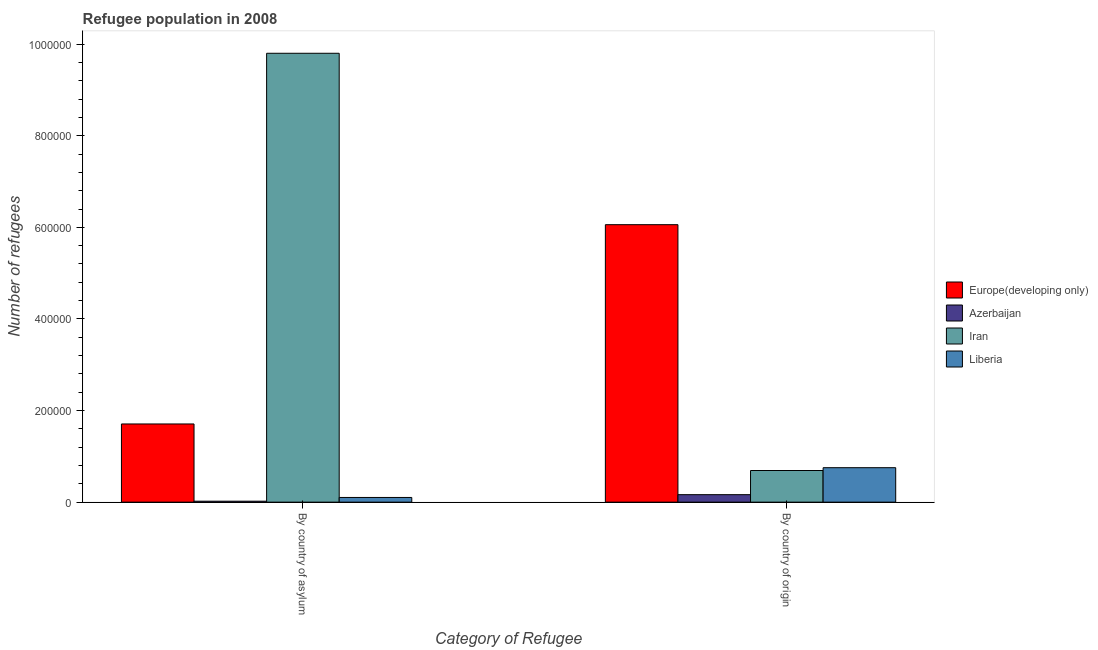How many different coloured bars are there?
Provide a succinct answer. 4. Are the number of bars per tick equal to the number of legend labels?
Your answer should be very brief. Yes. How many bars are there on the 1st tick from the right?
Give a very brief answer. 4. What is the label of the 2nd group of bars from the left?
Give a very brief answer. By country of origin. What is the number of refugees by country of origin in Liberia?
Your answer should be very brief. 7.52e+04. Across all countries, what is the maximum number of refugees by country of asylum?
Provide a succinct answer. 9.80e+05. Across all countries, what is the minimum number of refugees by country of asylum?
Provide a short and direct response. 2061. In which country was the number of refugees by country of origin maximum?
Your answer should be very brief. Europe(developing only). In which country was the number of refugees by country of origin minimum?
Make the answer very short. Azerbaijan. What is the total number of refugees by country of origin in the graph?
Provide a short and direct response. 7.66e+05. What is the difference between the number of refugees by country of origin in Liberia and that in Iran?
Offer a terse response. 6152. What is the difference between the number of refugees by country of asylum in Europe(developing only) and the number of refugees by country of origin in Iran?
Give a very brief answer. 1.02e+05. What is the average number of refugees by country of origin per country?
Provide a succinct answer. 1.92e+05. What is the difference between the number of refugees by country of origin and number of refugees by country of asylum in Liberia?
Offer a terse response. 6.50e+04. In how many countries, is the number of refugees by country of origin greater than 40000 ?
Your response must be concise. 3. What is the ratio of the number of refugees by country of asylum in Azerbaijan to that in Liberia?
Offer a terse response. 0.2. In how many countries, is the number of refugees by country of origin greater than the average number of refugees by country of origin taken over all countries?
Provide a succinct answer. 1. What does the 2nd bar from the left in By country of asylum represents?
Your answer should be compact. Azerbaijan. What does the 2nd bar from the right in By country of origin represents?
Provide a succinct answer. Iran. How many countries are there in the graph?
Your answer should be very brief. 4. Does the graph contain any zero values?
Offer a very short reply. No. Where does the legend appear in the graph?
Offer a terse response. Center right. How are the legend labels stacked?
Your answer should be compact. Vertical. What is the title of the graph?
Your answer should be very brief. Refugee population in 2008. Does "Israel" appear as one of the legend labels in the graph?
Your answer should be compact. No. What is the label or title of the X-axis?
Make the answer very short. Category of Refugee. What is the label or title of the Y-axis?
Offer a very short reply. Number of refugees. What is the Number of refugees of Europe(developing only) in By country of asylum?
Provide a succinct answer. 1.71e+05. What is the Number of refugees of Azerbaijan in By country of asylum?
Offer a terse response. 2061. What is the Number of refugees in Iran in By country of asylum?
Offer a very short reply. 9.80e+05. What is the Number of refugees in Liberia in By country of asylum?
Ensure brevity in your answer.  1.02e+04. What is the Number of refugees of Europe(developing only) in By country of origin?
Ensure brevity in your answer.  6.06e+05. What is the Number of refugees of Azerbaijan in By country of origin?
Your answer should be very brief. 1.63e+04. What is the Number of refugees in Iran in By country of origin?
Ensure brevity in your answer.  6.91e+04. What is the Number of refugees in Liberia in By country of origin?
Offer a terse response. 7.52e+04. Across all Category of Refugee, what is the maximum Number of refugees in Europe(developing only)?
Provide a short and direct response. 6.06e+05. Across all Category of Refugee, what is the maximum Number of refugees of Azerbaijan?
Keep it short and to the point. 1.63e+04. Across all Category of Refugee, what is the maximum Number of refugees of Iran?
Provide a succinct answer. 9.80e+05. Across all Category of Refugee, what is the maximum Number of refugees in Liberia?
Offer a terse response. 7.52e+04. Across all Category of Refugee, what is the minimum Number of refugees in Europe(developing only)?
Make the answer very short. 1.71e+05. Across all Category of Refugee, what is the minimum Number of refugees of Azerbaijan?
Your response must be concise. 2061. Across all Category of Refugee, what is the minimum Number of refugees in Iran?
Provide a succinct answer. 6.91e+04. Across all Category of Refugee, what is the minimum Number of refugees of Liberia?
Provide a short and direct response. 1.02e+04. What is the total Number of refugees in Europe(developing only) in the graph?
Make the answer very short. 7.77e+05. What is the total Number of refugees of Azerbaijan in the graph?
Offer a terse response. 1.84e+04. What is the total Number of refugees of Iran in the graph?
Provide a succinct answer. 1.05e+06. What is the total Number of refugees of Liberia in the graph?
Keep it short and to the point. 8.54e+04. What is the difference between the Number of refugees of Europe(developing only) in By country of asylum and that in By country of origin?
Offer a very short reply. -4.35e+05. What is the difference between the Number of refugees in Azerbaijan in By country of asylum and that in By country of origin?
Keep it short and to the point. -1.43e+04. What is the difference between the Number of refugees in Iran in By country of asylum and that in By country of origin?
Provide a short and direct response. 9.11e+05. What is the difference between the Number of refugees in Liberia in By country of asylum and that in By country of origin?
Give a very brief answer. -6.50e+04. What is the difference between the Number of refugees in Europe(developing only) in By country of asylum and the Number of refugees in Azerbaijan in By country of origin?
Keep it short and to the point. 1.54e+05. What is the difference between the Number of refugees in Europe(developing only) in By country of asylum and the Number of refugees in Iran in By country of origin?
Give a very brief answer. 1.02e+05. What is the difference between the Number of refugees of Europe(developing only) in By country of asylum and the Number of refugees of Liberia in By country of origin?
Offer a terse response. 9.55e+04. What is the difference between the Number of refugees of Azerbaijan in By country of asylum and the Number of refugees of Iran in By country of origin?
Your answer should be compact. -6.70e+04. What is the difference between the Number of refugees in Azerbaijan in By country of asylum and the Number of refugees in Liberia in By country of origin?
Make the answer very short. -7.32e+04. What is the difference between the Number of refugees of Iran in By country of asylum and the Number of refugees of Liberia in By country of origin?
Provide a short and direct response. 9.05e+05. What is the average Number of refugees of Europe(developing only) per Category of Refugee?
Your answer should be compact. 3.88e+05. What is the average Number of refugees of Azerbaijan per Category of Refugee?
Provide a succinct answer. 9190. What is the average Number of refugees of Iran per Category of Refugee?
Offer a terse response. 5.25e+05. What is the average Number of refugees of Liberia per Category of Refugee?
Make the answer very short. 4.27e+04. What is the difference between the Number of refugees of Europe(developing only) and Number of refugees of Azerbaijan in By country of asylum?
Ensure brevity in your answer.  1.69e+05. What is the difference between the Number of refugees of Europe(developing only) and Number of refugees of Iran in By country of asylum?
Your answer should be very brief. -8.09e+05. What is the difference between the Number of refugees in Europe(developing only) and Number of refugees in Liberia in By country of asylum?
Keep it short and to the point. 1.60e+05. What is the difference between the Number of refugees of Azerbaijan and Number of refugees of Iran in By country of asylum?
Provide a succinct answer. -9.78e+05. What is the difference between the Number of refugees in Azerbaijan and Number of refugees in Liberia in By country of asylum?
Provide a succinct answer. -8163. What is the difference between the Number of refugees in Iran and Number of refugees in Liberia in By country of asylum?
Your response must be concise. 9.70e+05. What is the difference between the Number of refugees of Europe(developing only) and Number of refugees of Azerbaijan in By country of origin?
Offer a terse response. 5.90e+05. What is the difference between the Number of refugees in Europe(developing only) and Number of refugees in Iran in By country of origin?
Provide a short and direct response. 5.37e+05. What is the difference between the Number of refugees of Europe(developing only) and Number of refugees of Liberia in By country of origin?
Offer a terse response. 5.31e+05. What is the difference between the Number of refugees in Azerbaijan and Number of refugees in Iran in By country of origin?
Ensure brevity in your answer.  -5.27e+04. What is the difference between the Number of refugees of Azerbaijan and Number of refugees of Liberia in By country of origin?
Your answer should be compact. -5.89e+04. What is the difference between the Number of refugees of Iran and Number of refugees of Liberia in By country of origin?
Provide a short and direct response. -6152. What is the ratio of the Number of refugees in Europe(developing only) in By country of asylum to that in By country of origin?
Your response must be concise. 0.28. What is the ratio of the Number of refugees in Azerbaijan in By country of asylum to that in By country of origin?
Your response must be concise. 0.13. What is the ratio of the Number of refugees of Iran in By country of asylum to that in By country of origin?
Offer a very short reply. 14.19. What is the ratio of the Number of refugees in Liberia in By country of asylum to that in By country of origin?
Your answer should be compact. 0.14. What is the difference between the highest and the second highest Number of refugees in Europe(developing only)?
Your response must be concise. 4.35e+05. What is the difference between the highest and the second highest Number of refugees of Azerbaijan?
Make the answer very short. 1.43e+04. What is the difference between the highest and the second highest Number of refugees in Iran?
Ensure brevity in your answer.  9.11e+05. What is the difference between the highest and the second highest Number of refugees of Liberia?
Offer a very short reply. 6.50e+04. What is the difference between the highest and the lowest Number of refugees of Europe(developing only)?
Provide a succinct answer. 4.35e+05. What is the difference between the highest and the lowest Number of refugees of Azerbaijan?
Make the answer very short. 1.43e+04. What is the difference between the highest and the lowest Number of refugees in Iran?
Your response must be concise. 9.11e+05. What is the difference between the highest and the lowest Number of refugees of Liberia?
Keep it short and to the point. 6.50e+04. 